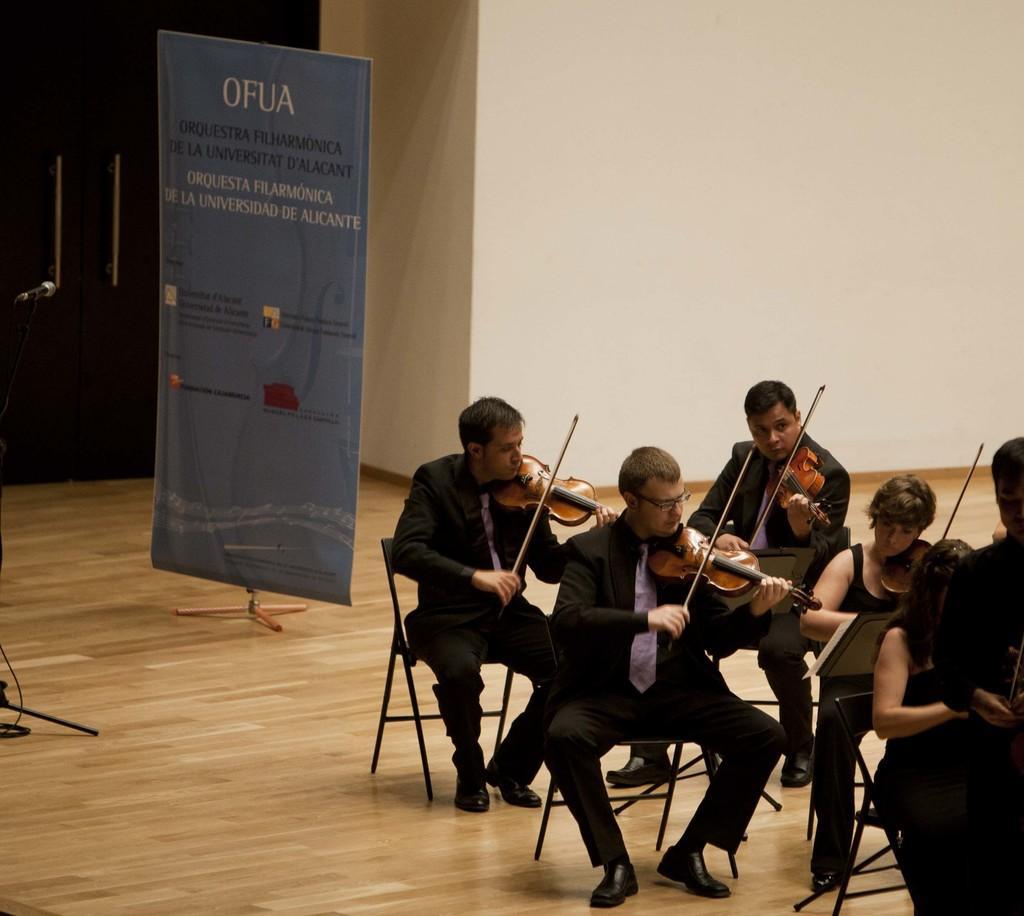Could you give a brief overview of what you see in this image? Bunch of men and women playing violin sitting on chair on a wooden floor. All wore black dresses. There is a poster with text on it held on a tripod stand. There is a mic placed on left side corner with the aid of a stand. 